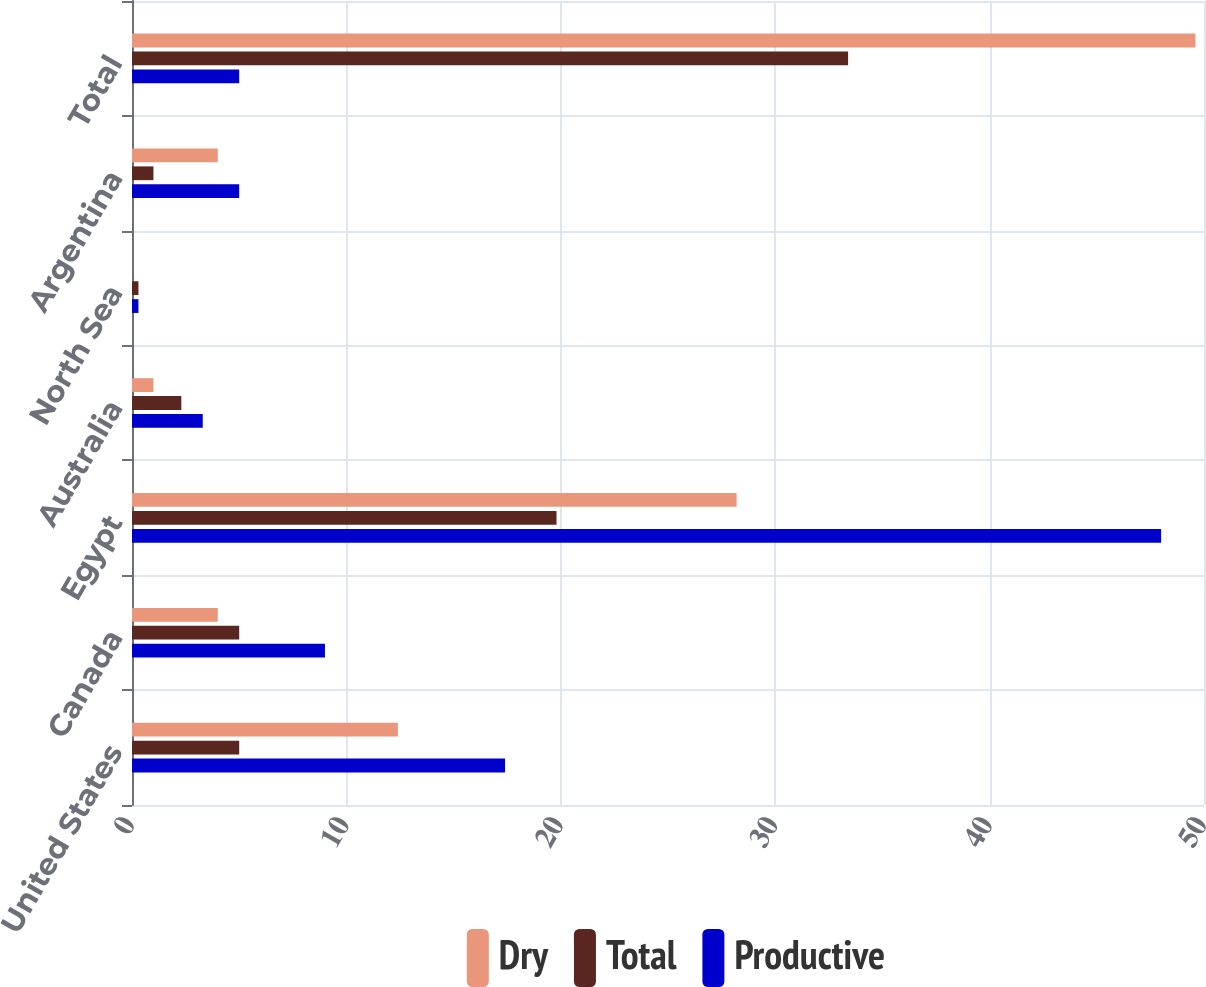Convert chart to OTSL. <chart><loc_0><loc_0><loc_500><loc_500><stacked_bar_chart><ecel><fcel>United States<fcel>Canada<fcel>Egypt<fcel>Australia<fcel>North Sea<fcel>Argentina<fcel>Total<nl><fcel>Dry<fcel>12.4<fcel>4<fcel>28.2<fcel>1<fcel>0<fcel>4<fcel>49.6<nl><fcel>Total<fcel>5<fcel>5<fcel>19.8<fcel>2.3<fcel>0.3<fcel>1<fcel>33.4<nl><fcel>Productive<fcel>17.4<fcel>9<fcel>48<fcel>3.3<fcel>0.3<fcel>5<fcel>5<nl></chart> 